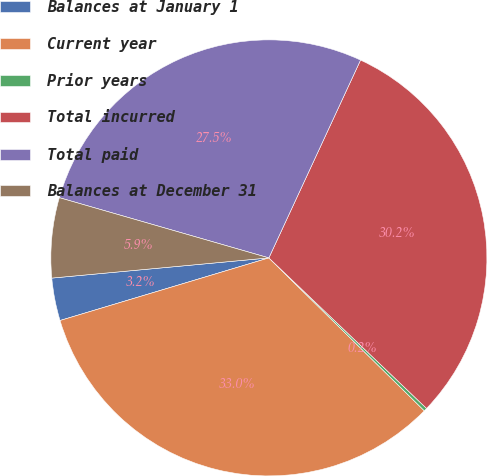Convert chart to OTSL. <chart><loc_0><loc_0><loc_500><loc_500><pie_chart><fcel>Balances at January 1<fcel>Current year<fcel>Prior years<fcel>Total incurred<fcel>Total paid<fcel>Balances at December 31<nl><fcel>3.16%<fcel>32.99%<fcel>0.24%<fcel>30.22%<fcel>27.45%<fcel>5.93%<nl></chart> 